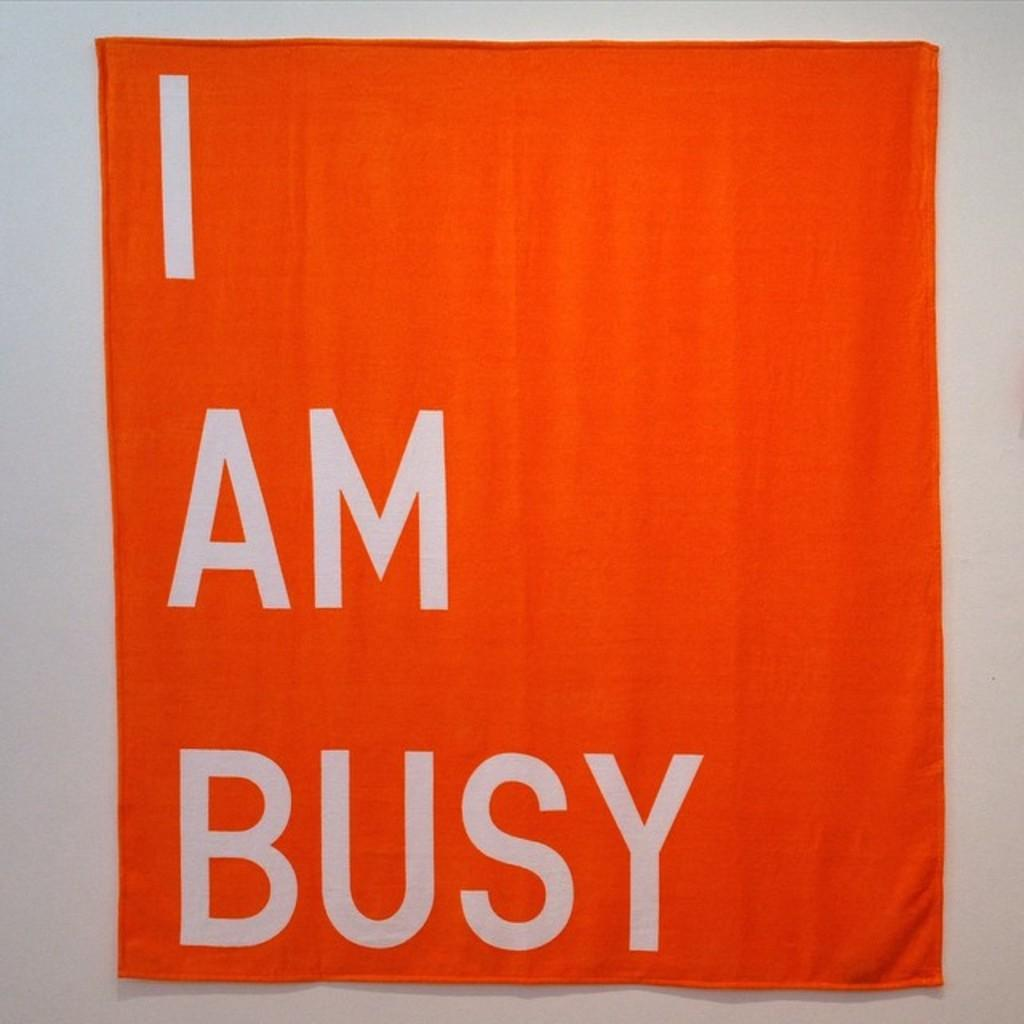<image>
Summarize the visual content of the image. An orange rectangular flag that says I am busy. 